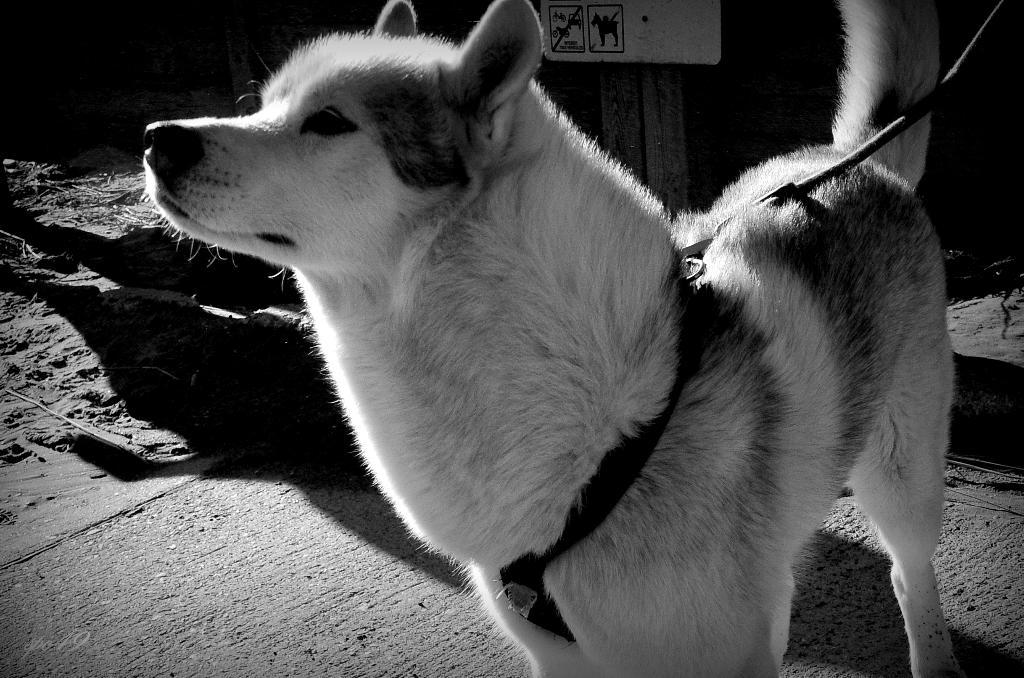What type of animal is in the image? There is a dog in the image. Where is the dog located? The dog is on the ground. What is the dog wearing? The dog has a belt on it. What can be seen in the background of the image? There is a board visible in the background of the image. What type of dress is the dog wearing in the image? The dog is not wearing a dress in the image; it has a belt on. 